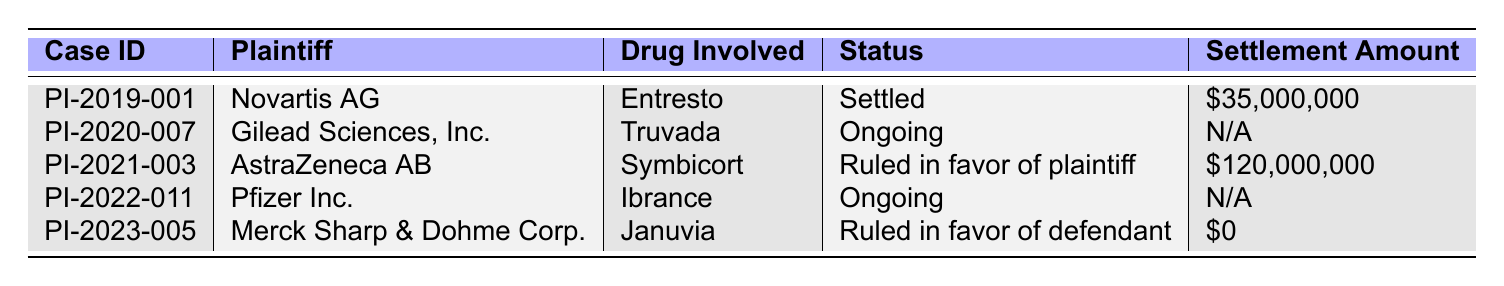What is the case ID for the patent infringement case filed by Novartis AG? The case file for Novartis AG has the ID listed in the table as PI-2019-001.
Answer: PI-2019-001 Which patent number is associated with the case involving AstraZeneca AB? The patent number related to AstraZeneca AB’s case can be found in the table and is US7951785.
Answer: US7951785 How many cases are listed as ongoing? By reviewing the status column, two cases are marked as "Ongoing." They involve Gilead Sciences and Pfizer Inc.
Answer: 2 What is the status of the case involving Gilead Sciences, Inc.? The status listed for the case filed by Gilead Sciences, Inc. is "Ongoing."
Answer: Ongoing What is the total settlement amount for the cases that have been settled? To find the total amount, I add the settlement amounts of the settled cases: $35,000,000 (Novartis) + $120,000,000 (AstraZeneca) = $155,000,000.
Answer: $155,000,000 Was there a case ruled in favor of the defendant? Reviewing the status of each case, the case involving Merck Sharp & Dohme Corp. was ruled in favor of the defendant. Therefore, the answer to this question is yes.
Answer: Yes What is the drug involved in the case filed by Pfizer Inc.? The table specifies that the drug involved in the case against Pfizer Inc. is Ibrance.
Answer: Ibrance Who were the plaintiffs that filed cases against the company in 2021 and 2023? For 2021, the plaintiff was AstraZeneca AB, and for 2023, it was Merck Sharp & Dohme Corp. This is indicated in the table under the respective years.
Answer: AstraZeneca AB and Merck Sharp & Dohme Corp What is the difference in settlement amounts between the cases by Novartis AG and AstraZeneca AB? The settlement amount for Novartis AG is $35,000,000 and for AstraZeneca AB is $120,000,000. The difference is $120,000,000 - $35,000,000 = $85,000,000.
Answer: $85,000,000 Which patent infringement case has the highest settlement amount, and what is that amount? The case with the highest settlement amount is the one involving AstraZeneca AB, with a settlement amount of $120,000,000.
Answer: $120,000,000 